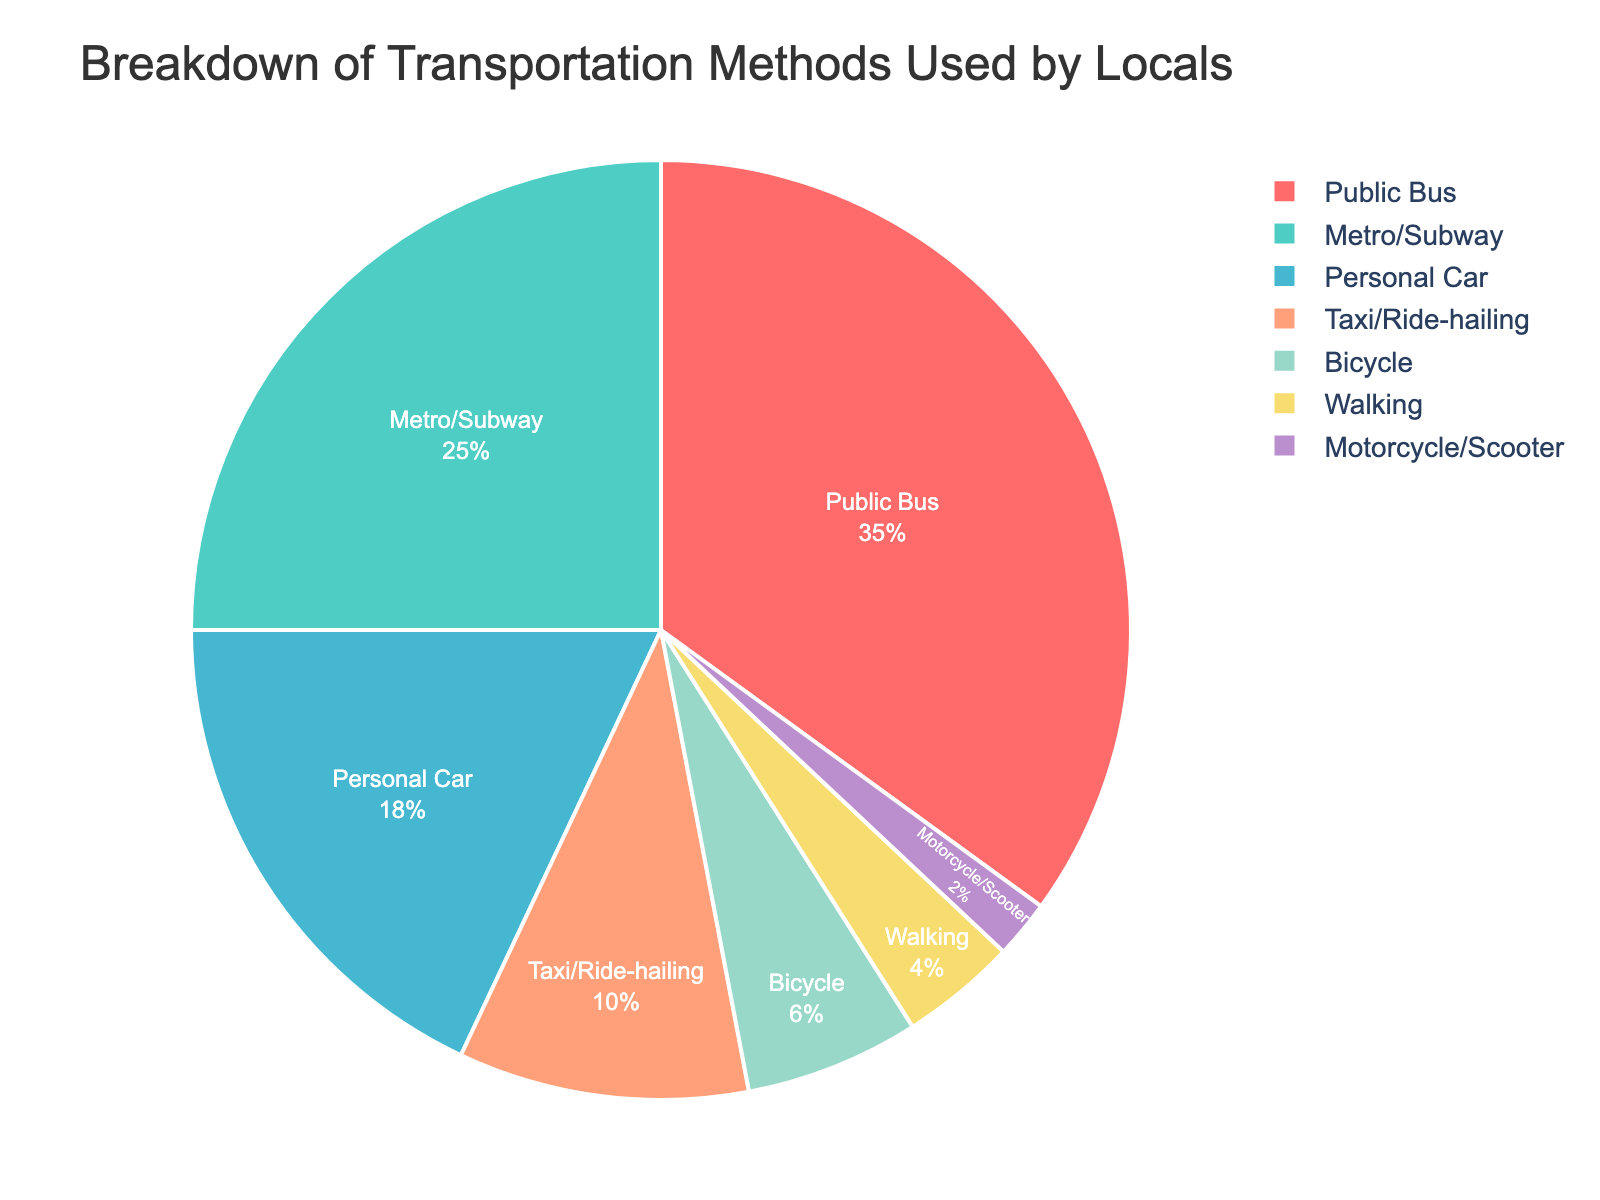What's the most commonly used transportation method by locals? The pie chart shows different transportation methods with the corresponding percentages. The method with the highest percentage is the most commonly used. Here, the Public Bus has the highest percentage at 35%.
Answer: Public Bus How much more popular is the Public Bus compared to Walking? The percentage for Public Bus is 35% and for Walking is 4%. The difference is calculated by subtracting 4% from 35%, which equals 31%.
Answer: 31% What proportion of locals use either a Personal Car or a Motorcycle/Scooter combined? The percentage for Personal Car is 18% and for Motorcycle/Scooter is 2%. Adding these percentages together gives 18% + 2% = 20%.
Answer: 20% Which transportation method is the least common among locals? The pie chart shows the percentage of each transportation method. The method with the smallest percentage is the least common, which here is Motorcycle/Scooter at 2%.
Answer: Motorcycle/Scooter What percentage of locals utilize non-motorized transportation methods (Bicycle and Walking)? The pie chart shows the percentages for Bicycle and Walking. Adding these percentages together gives 6% + 4% = 10%.
Answer: 10% Are there more locals using Metro/Subway than Personal Car? The pie chart shows the percentage for Metro/Subway as 25% and for Personal Car as 18%. Since 25% is greater than 18%, more locals use the Metro/Subway than a Personal Car.
Answer: Yes What's the combined percentage for Public Bus, Metro/Subway, and Bicycle use? The chart shows the percentages for Public Bus, Metro/Subway, and Bicycle as 35%, 25%, and 6% respectively. Adding these together gives 35% + 25% + 6% = 66%.
Answer: 66% By how much does the percentage of Bicycle users exceed that of Motorcycle/Scooter users? The chart shows the percentage for Bicycle as 6% and for Motorcycle/Scooter as 2%. Subtracting 2% from 6% gives 4%.
Answer: 4% Which transportation methods have a combined usage of less than 10% when added together? The chart shows the individual percentages: Taxi/Ride-hailing (10%), Bicycle (6%), Walking (4%), and Motorcycle/Scooter (2%). Adding combinations until the sum is less than 10%: Motorcycle/Scooter (2%) + Walking (4%) = 6%, which is less than 10%.
Answer: Motorcycle/Scooter and Walking If the usage of each transportation method were equally divided among 10 people, how many people would use the Personal Car? The percentage for Personal Car is 18%. If 10 people represent 100%, each person represents 10%. Therefore, 18% corresponds to 1.8 people.
Answer: 1.8 people 